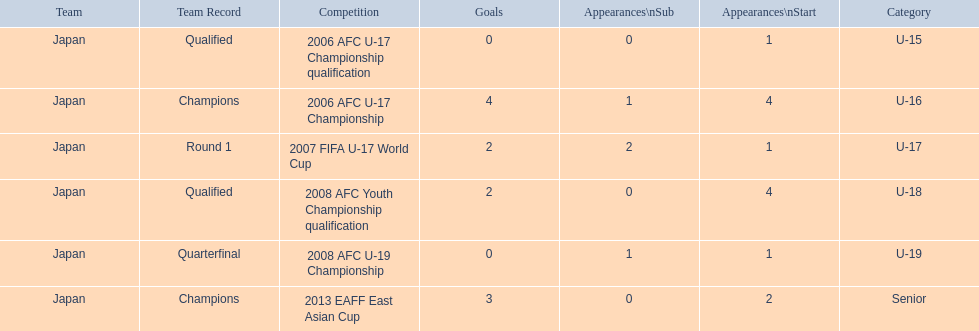Which competitions has yoichiro kakitani participated in? 2006 AFC U-17 Championship qualification, 2006 AFC U-17 Championship, 2007 FIFA U-17 World Cup, 2008 AFC Youth Championship qualification, 2008 AFC U-19 Championship, 2013 EAFF East Asian Cup. How many times did he start during each competition? 1, 4, 1, 4, 1, 2. How many goals did he score during those? 0, 4, 2, 2, 0, 3. And during which competition did yoichiro achieve the most starts and goals? 2006 AFC U-17 Championship. 